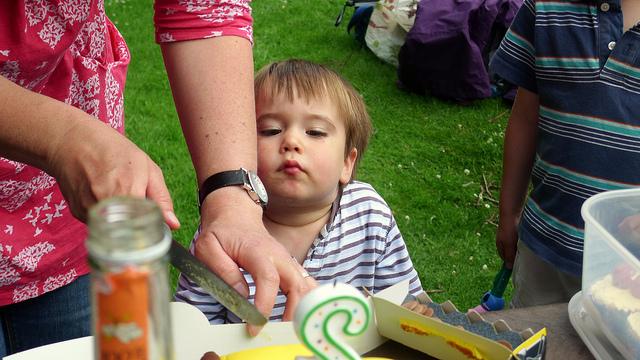How old is the child turning?
Quick response, please. 2. Who is holding the knife?
Be succinct. Mom. Is it warm or cold in the pic?
Give a very brief answer. Warm. Is the knife dirty?
Answer briefly. Yes. 